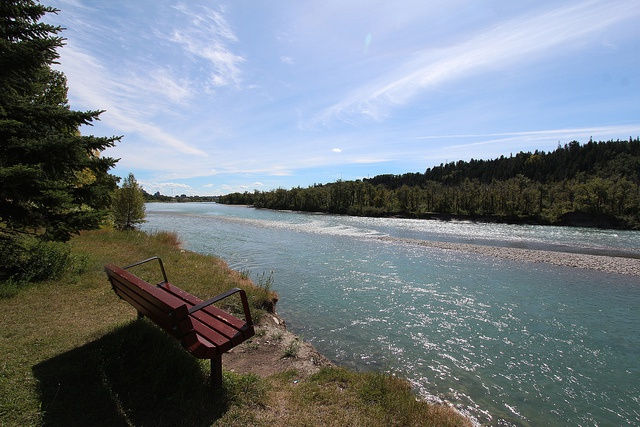Describe the objects in this image and their specific colors. I can see a bench in black, maroon, darkgreen, and brown tones in this image. 